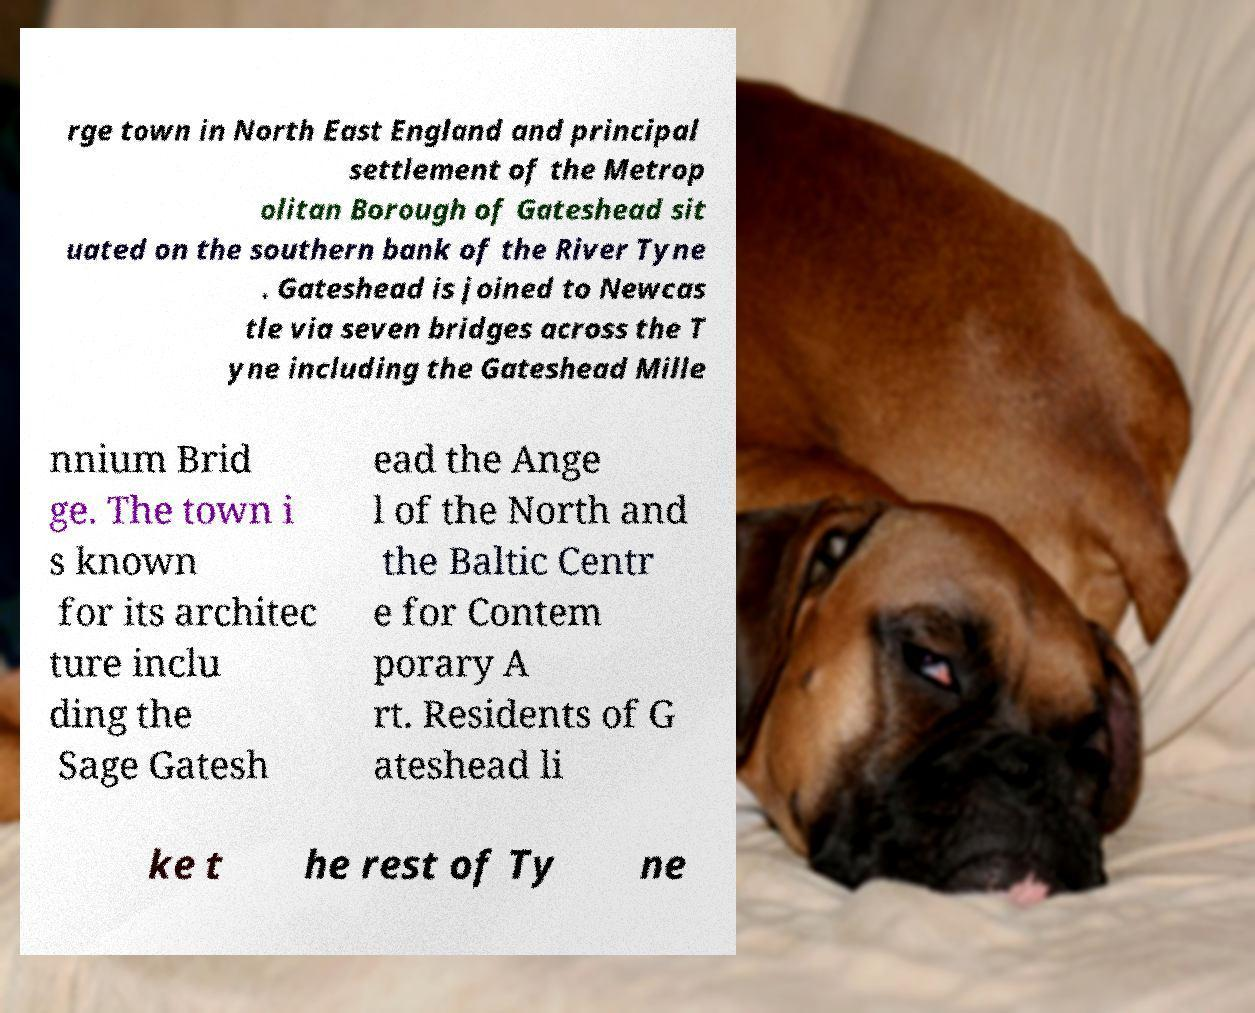Can you accurately transcribe the text from the provided image for me? rge town in North East England and principal settlement of the Metrop olitan Borough of Gateshead sit uated on the southern bank of the River Tyne . Gateshead is joined to Newcas tle via seven bridges across the T yne including the Gateshead Mille nnium Brid ge. The town i s known for its architec ture inclu ding the Sage Gatesh ead the Ange l of the North and the Baltic Centr e for Contem porary A rt. Residents of G ateshead li ke t he rest of Ty ne 